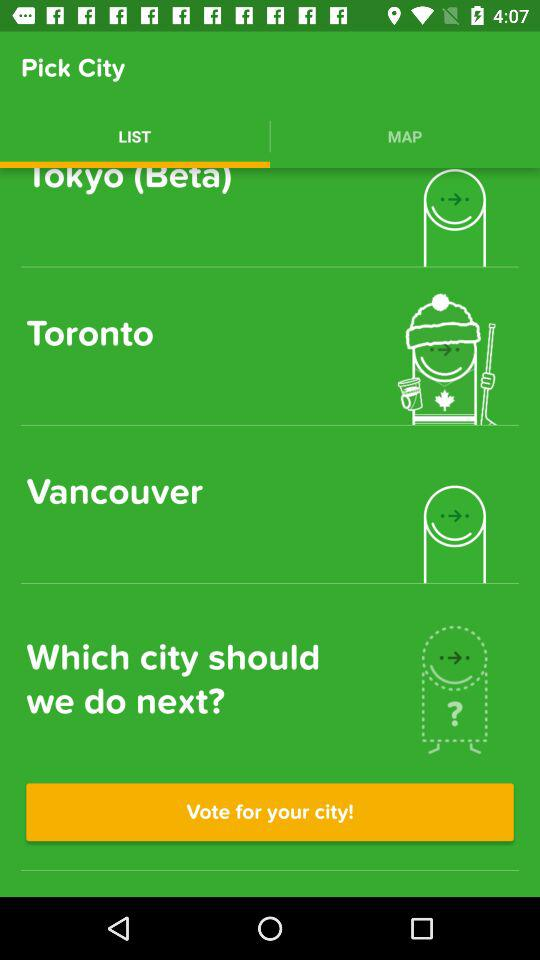How many cities are available to vote for?
Answer the question using a single word or phrase. 3 